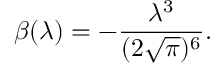<formula> <loc_0><loc_0><loc_500><loc_500>\beta ( \lambda ) = - \frac { \lambda ^ { 3 } } { ( 2 \sqrt { \pi } ) ^ { 6 } } .</formula> 